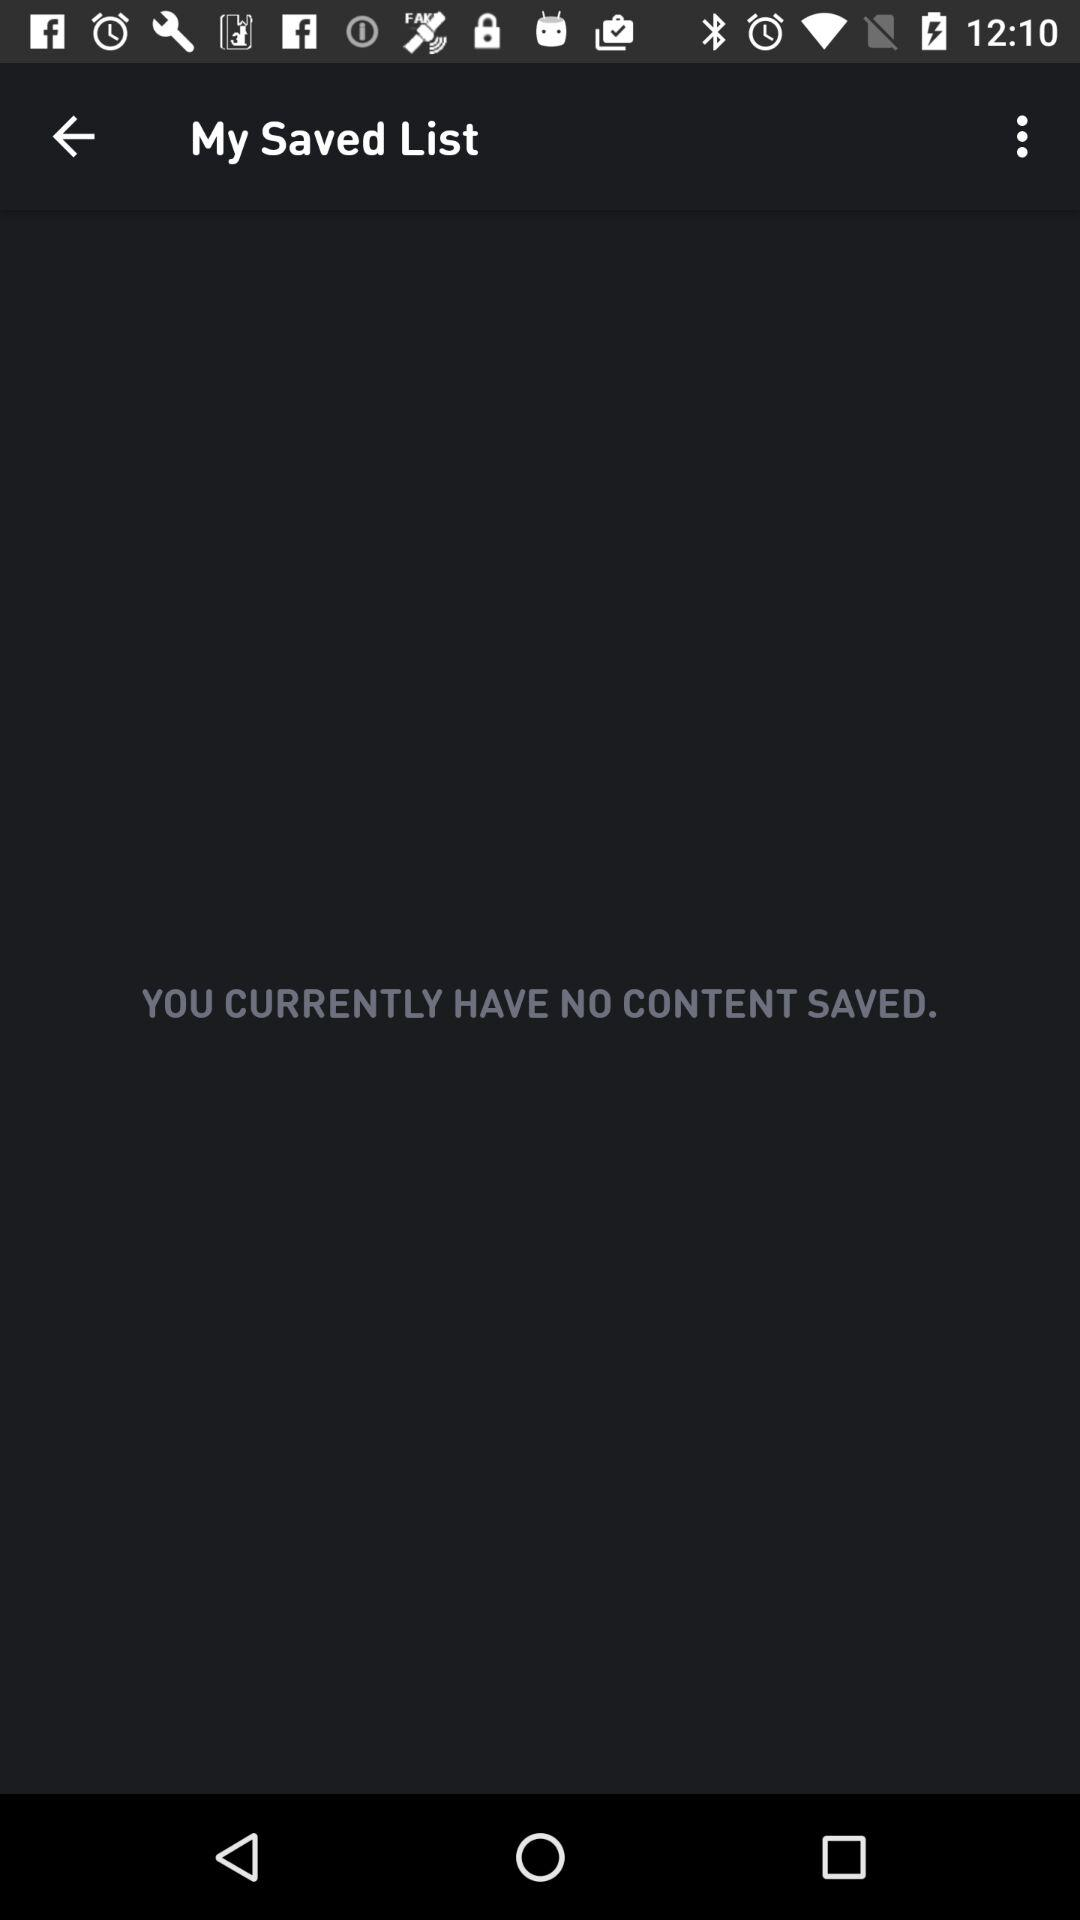How many saved items do I have?
Answer the question using a single word or phrase. 0 